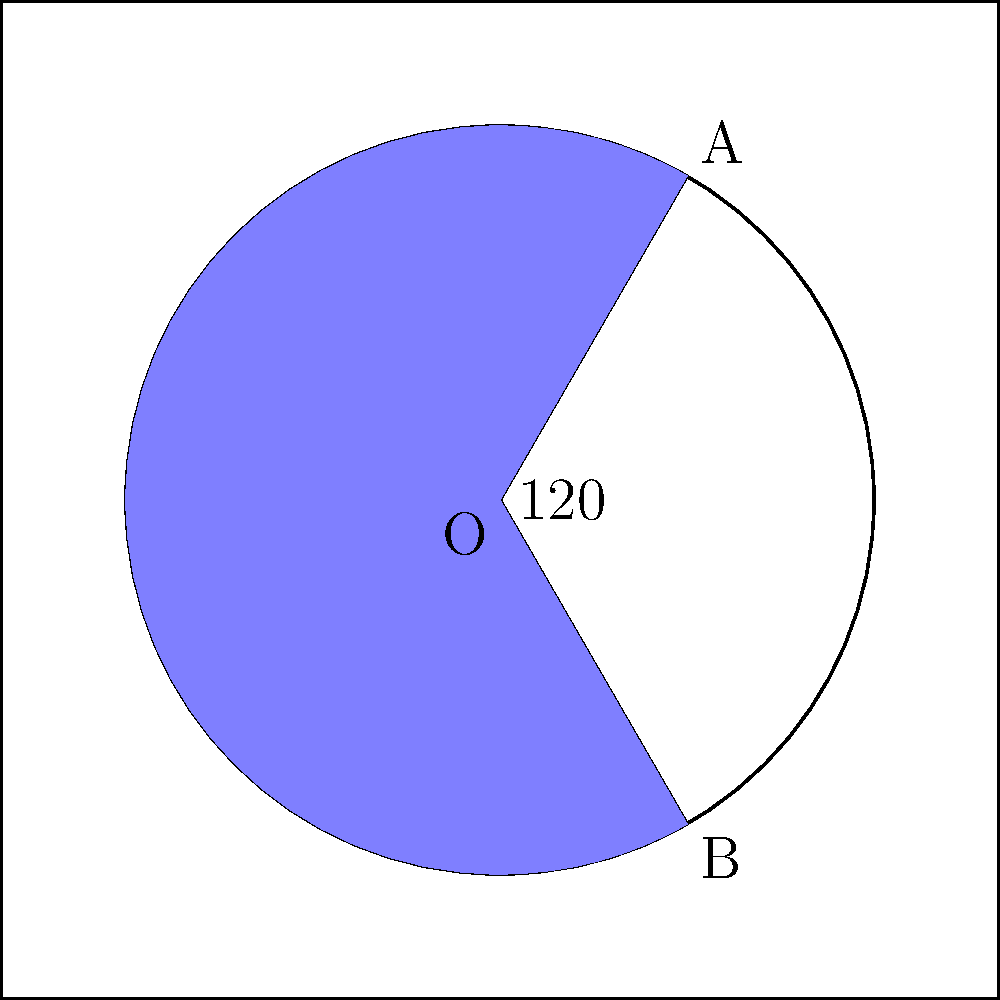A circular fund distribution model is being considered for women's programs, represented by a circle with radius 3 units. If a segment of the circle covering a central angle of 120° is allocated for healthcare initiatives, what fraction of the total fund does this segment represent? To solve this problem, we need to follow these steps:

1. Calculate the area of the entire circle:
   $$A_{circle} = \pi r^2 = \pi \cdot 3^2 = 9\pi$$

2. Calculate the area of the circular segment:
   The formula for the area of a circular segment is:
   $$A_{segment} = \frac{r^2}{2}(\theta - \sin\theta)$$
   where $\theta$ is in radians.

3. Convert the angle from degrees to radians:
   $$120° = \frac{120 \cdot \pi}{180} = \frac{2\pi}{3} \approx 2.0944$$

4. Calculate the area of the segment:
   $$A_{segment} = \frac{3^2}{2}(\frac{2\pi}{3} - \sin(\frac{2\pi}{3}))$$
   $$= \frac{9}{2}(\frac{2\pi}{3} - \frac{\sqrt{3}}{2})$$
   $$\approx 4.7124$$

5. Calculate the fraction of the total area:
   $$\text{Fraction} = \frac{A_{segment}}{A_{circle}} = \frac{4.7124}{9\pi} \approx 0.1667$$

This fraction can be simplified to $\frac{1}{6}$.
Answer: $\frac{1}{6}$ 